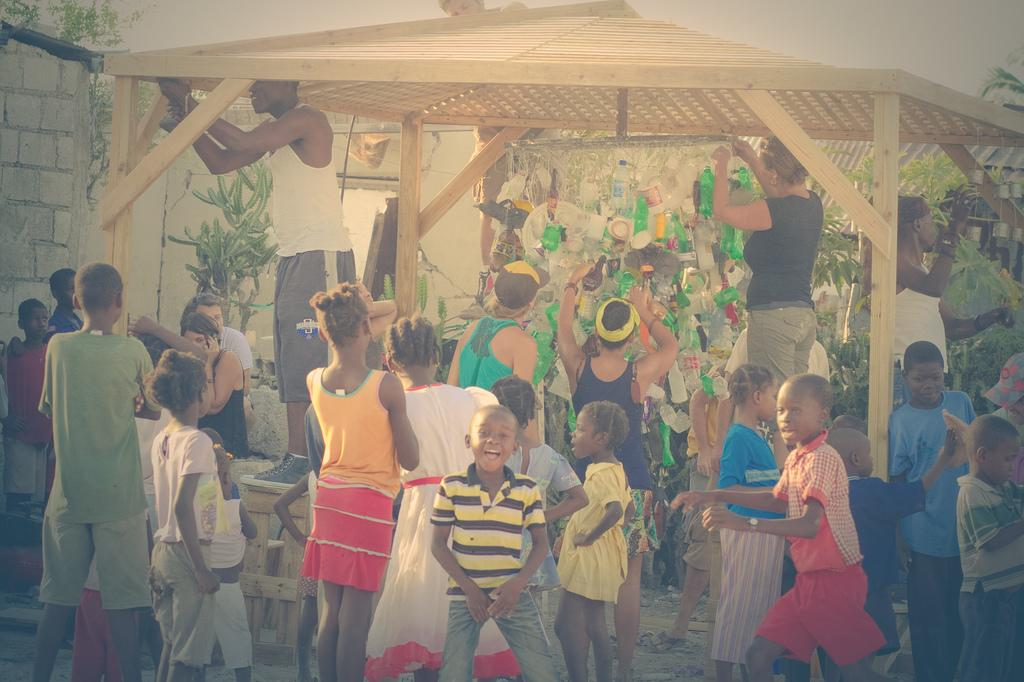What is the main subject of the image? There is a boy standing in the center of the image. What is the boy's expression in the image? The boy is smiling. What can be seen in the background of the image? There is a wall, a shed, bottles, trees, plants, people sitting, and people standing in the background of the image. What type of winter sport is the boy participating in the image? There is no indication of a winter sport or any sports activity in the image. 